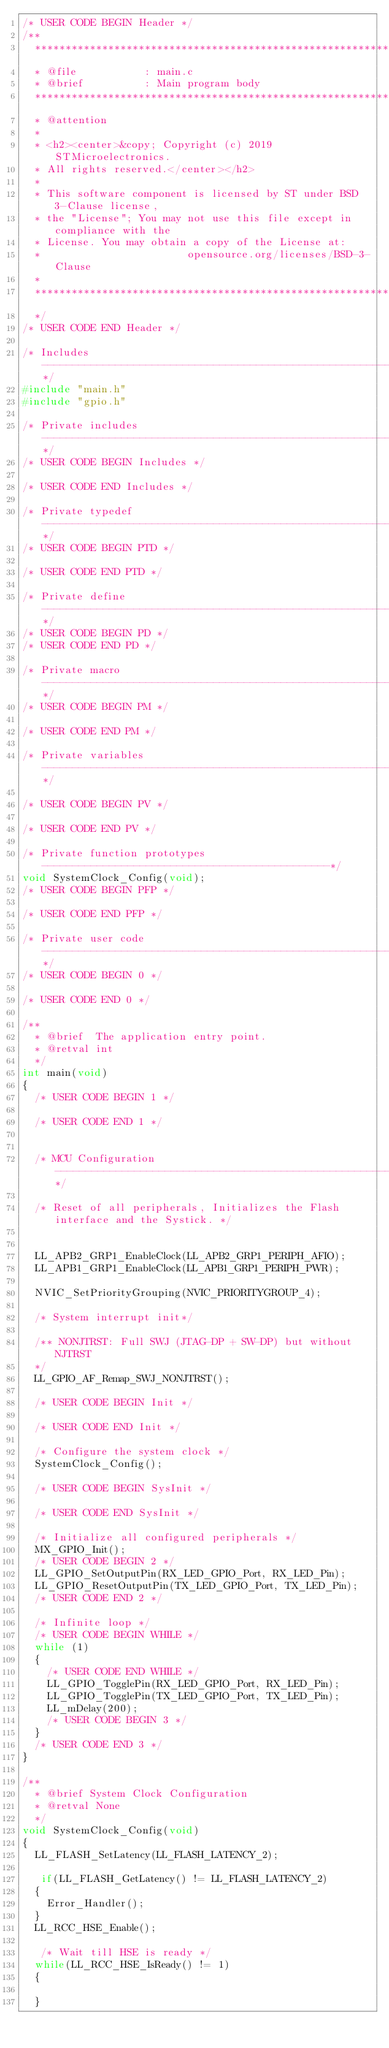<code> <loc_0><loc_0><loc_500><loc_500><_C_>/* USER CODE BEGIN Header */
/**
  ******************************************************************************
  * @file           : main.c
  * @brief          : Main program body
  ******************************************************************************
  * @attention
  *
  * <h2><center>&copy; Copyright (c) 2019 STMicroelectronics.
  * All rights reserved.</center></h2>
  *
  * This software component is licensed by ST under BSD 3-Clause license,
  * the "License"; You may not use this file except in compliance with the
  * License. You may obtain a copy of the License at:
  *                        opensource.org/licenses/BSD-3-Clause
  *
  ******************************************************************************
  */
/* USER CODE END Header */

/* Includes ------------------------------------------------------------------*/
#include "main.h"
#include "gpio.h"

/* Private includes ----------------------------------------------------------*/
/* USER CODE BEGIN Includes */

/* USER CODE END Includes */

/* Private typedef -----------------------------------------------------------*/
/* USER CODE BEGIN PTD */

/* USER CODE END PTD */

/* Private define ------------------------------------------------------------*/
/* USER CODE BEGIN PD */
/* USER CODE END PD */

/* Private macro -------------------------------------------------------------*/
/* USER CODE BEGIN PM */

/* USER CODE END PM */

/* Private variables ---------------------------------------------------------*/

/* USER CODE BEGIN PV */

/* USER CODE END PV */

/* Private function prototypes -----------------------------------------------*/
void SystemClock_Config(void);
/* USER CODE BEGIN PFP */

/* USER CODE END PFP */

/* Private user code ---------------------------------------------------------*/
/* USER CODE BEGIN 0 */

/* USER CODE END 0 */

/**
  * @brief  The application entry point.
  * @retval int
  */
int main(void)
{
  /* USER CODE BEGIN 1 */

  /* USER CODE END 1 */
  

  /* MCU Configuration--------------------------------------------------------*/

  /* Reset of all peripherals, Initializes the Flash interface and the Systick. */
  

  LL_APB2_GRP1_EnableClock(LL_APB2_GRP1_PERIPH_AFIO);
  LL_APB1_GRP1_EnableClock(LL_APB1_GRP1_PERIPH_PWR);

  NVIC_SetPriorityGrouping(NVIC_PRIORITYGROUP_4);

  /* System interrupt init*/

  /** NONJTRST: Full SWJ (JTAG-DP + SW-DP) but without NJTRST 
  */
  LL_GPIO_AF_Remap_SWJ_NONJTRST();

  /* USER CODE BEGIN Init */

  /* USER CODE END Init */

  /* Configure the system clock */
  SystemClock_Config();

  /* USER CODE BEGIN SysInit */

  /* USER CODE END SysInit */

  /* Initialize all configured peripherals */
  MX_GPIO_Init();
  /* USER CODE BEGIN 2 */
  LL_GPIO_SetOutputPin(RX_LED_GPIO_Port, RX_LED_Pin);
  LL_GPIO_ResetOutputPin(TX_LED_GPIO_Port, TX_LED_Pin);
  /* USER CODE END 2 */

  /* Infinite loop */
  /* USER CODE BEGIN WHILE */
  while (1)
  {
    /* USER CODE END WHILE */
    LL_GPIO_TogglePin(RX_LED_GPIO_Port, RX_LED_Pin);
    LL_GPIO_TogglePin(TX_LED_GPIO_Port, TX_LED_Pin);
    LL_mDelay(200);
    /* USER CODE BEGIN 3 */
  }
  /* USER CODE END 3 */
}

/**
  * @brief System Clock Configuration
  * @retval None
  */
void SystemClock_Config(void)
{
  LL_FLASH_SetLatency(LL_FLASH_LATENCY_2);

   if(LL_FLASH_GetLatency() != LL_FLASH_LATENCY_2)
  {
    Error_Handler();  
  }
  LL_RCC_HSE_Enable();

   /* Wait till HSE is ready */
  while(LL_RCC_HSE_IsReady() != 1)
  {
    
  }</code> 